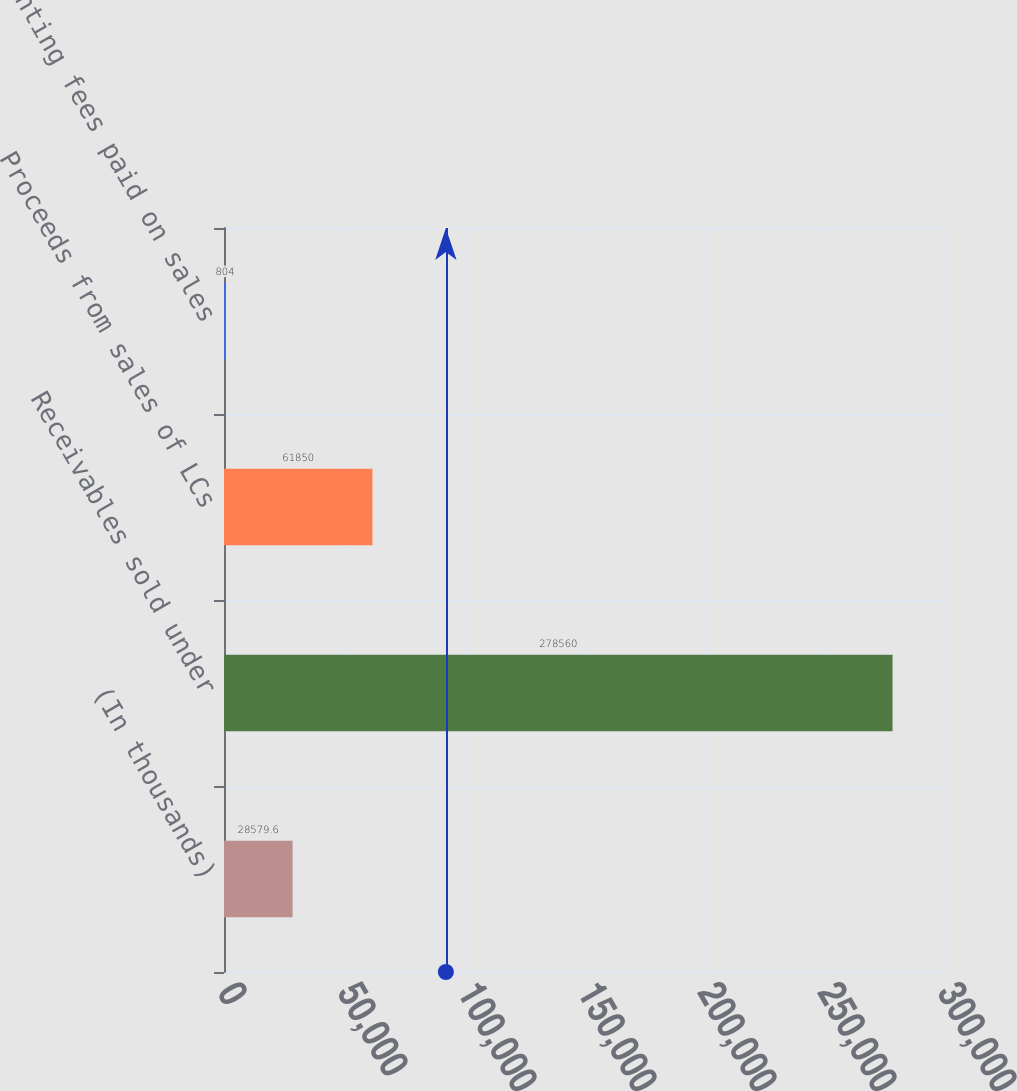Convert chart. <chart><loc_0><loc_0><loc_500><loc_500><bar_chart><fcel>(In thousands)<fcel>Receivables sold under<fcel>Proceeds from sales of LCs<fcel>Discounting fees paid on sales<nl><fcel>28579.6<fcel>278560<fcel>61850<fcel>804<nl></chart> 